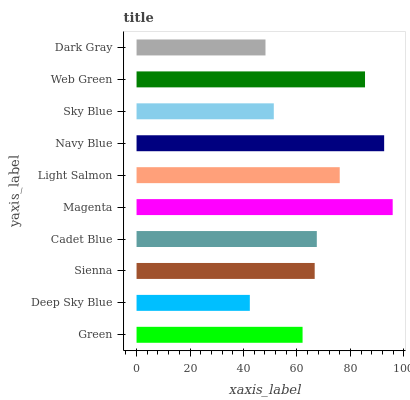Is Deep Sky Blue the minimum?
Answer yes or no. Yes. Is Magenta the maximum?
Answer yes or no. Yes. Is Sienna the minimum?
Answer yes or no. No. Is Sienna the maximum?
Answer yes or no. No. Is Sienna greater than Deep Sky Blue?
Answer yes or no. Yes. Is Deep Sky Blue less than Sienna?
Answer yes or no. Yes. Is Deep Sky Blue greater than Sienna?
Answer yes or no. No. Is Sienna less than Deep Sky Blue?
Answer yes or no. No. Is Cadet Blue the high median?
Answer yes or no. Yes. Is Sienna the low median?
Answer yes or no. Yes. Is Dark Gray the high median?
Answer yes or no. No. Is Cadet Blue the low median?
Answer yes or no. No. 